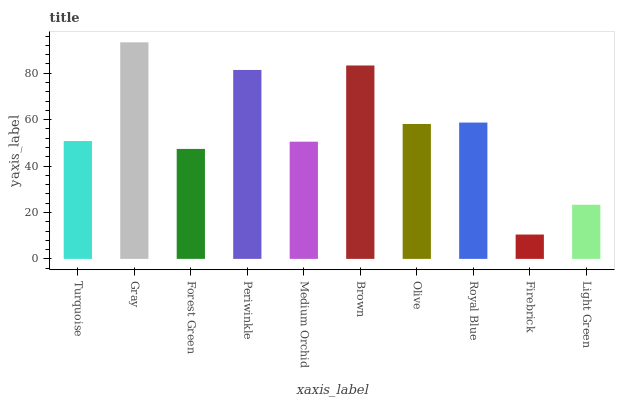Is Forest Green the minimum?
Answer yes or no. No. Is Forest Green the maximum?
Answer yes or no. No. Is Gray greater than Forest Green?
Answer yes or no. Yes. Is Forest Green less than Gray?
Answer yes or no. Yes. Is Forest Green greater than Gray?
Answer yes or no. No. Is Gray less than Forest Green?
Answer yes or no. No. Is Olive the high median?
Answer yes or no. Yes. Is Turquoise the low median?
Answer yes or no. Yes. Is Turquoise the high median?
Answer yes or no. No. Is Royal Blue the low median?
Answer yes or no. No. 